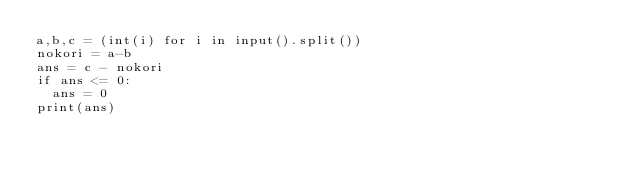<code> <loc_0><loc_0><loc_500><loc_500><_Python_>a,b,c = (int(i) for i in input().split())
nokori = a-b
ans = c - nokori
if ans <= 0:
  ans = 0
print(ans)
  </code> 